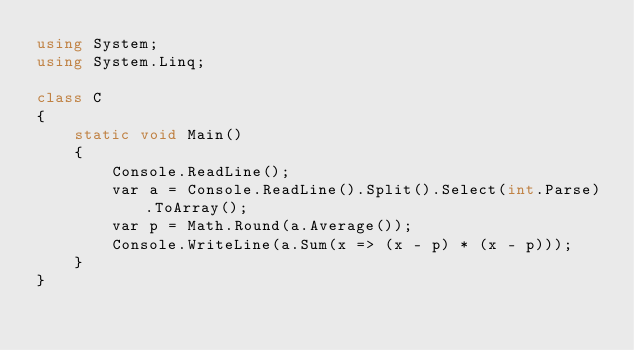<code> <loc_0><loc_0><loc_500><loc_500><_C#_>using System;
using System.Linq;

class C
{
	static void Main()
	{
		Console.ReadLine();
		var a = Console.ReadLine().Split().Select(int.Parse).ToArray();
		var p = Math.Round(a.Average());
		Console.WriteLine(a.Sum(x => (x - p) * (x - p)));
	}
}
</code> 